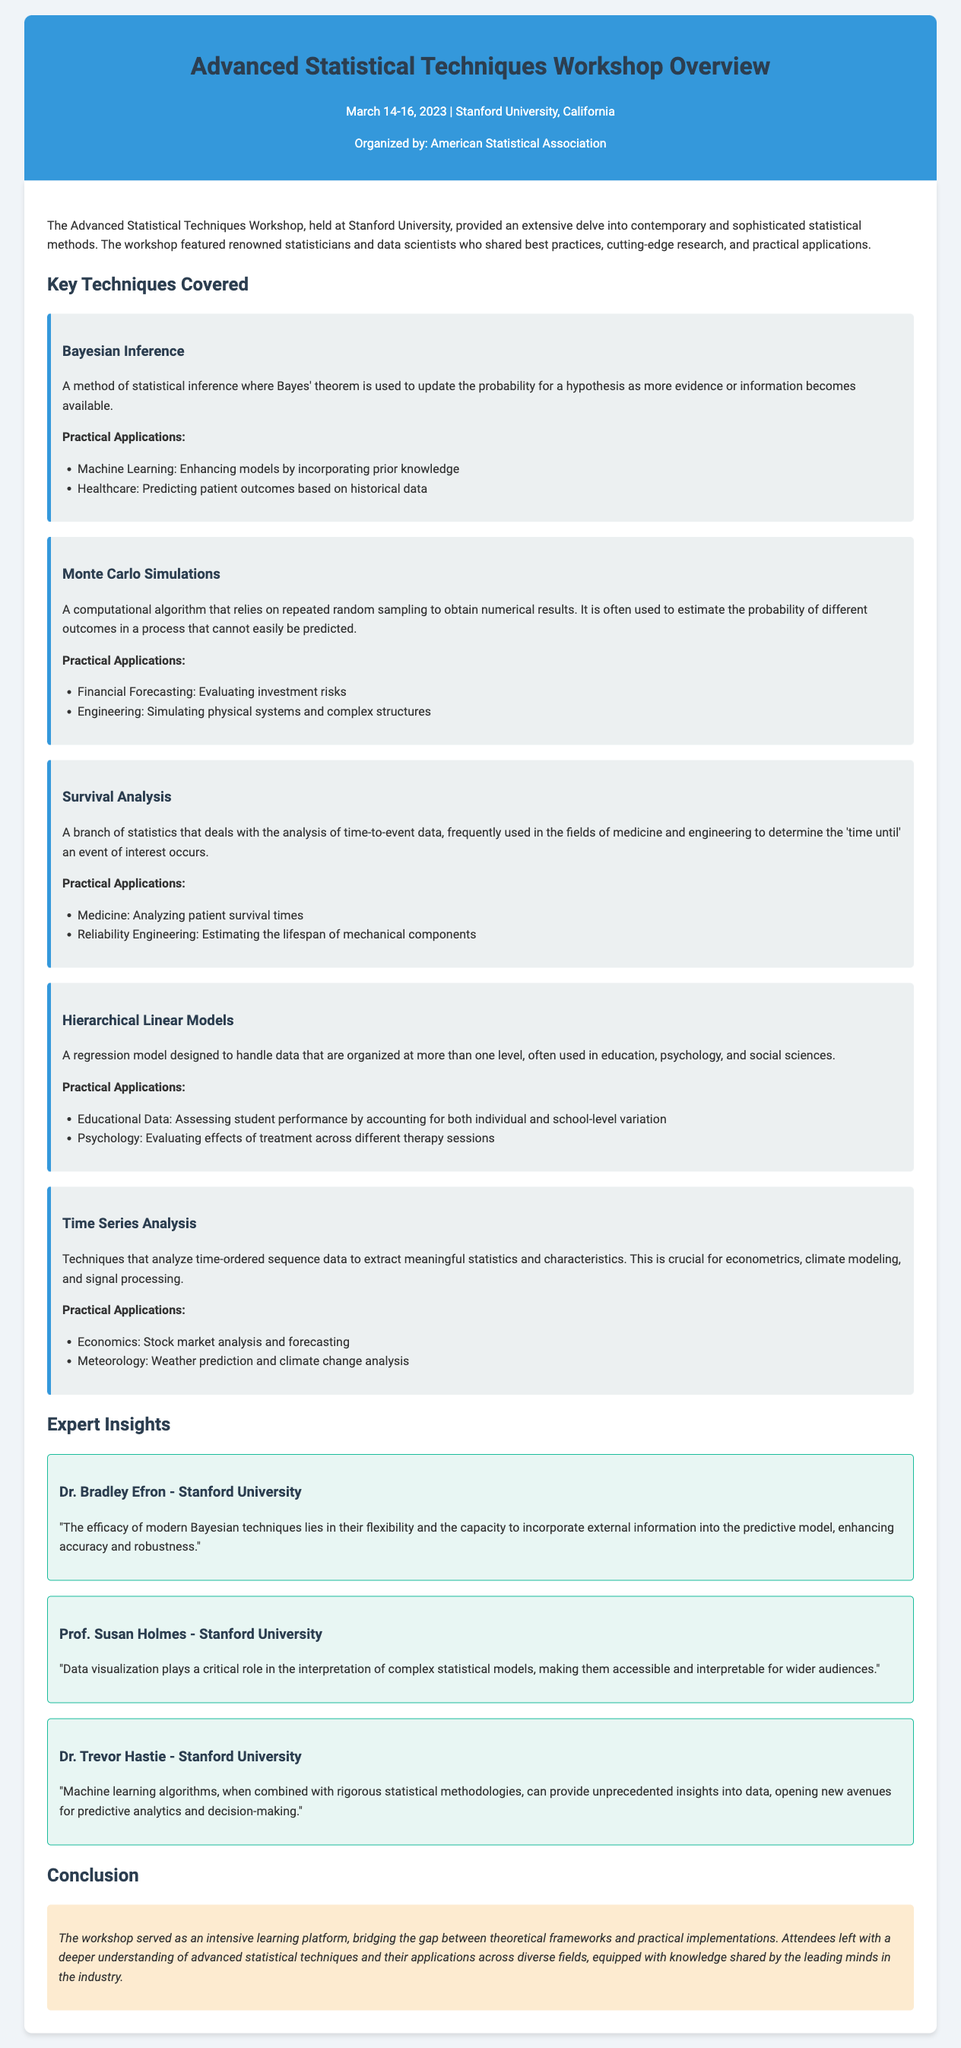What are the dates of the workshop? The workshop took place from March 14 to March 16, 2023.
Answer: March 14-16, 2023 Where was the workshop held? The document states that the workshop was held at Stanford University, California.
Answer: Stanford University, California Who organized the workshop? The organizer of the workshop mentioned in the document is the American Statistical Association.
Answer: American Statistical Association What is one practical application of Bayesian Inference? The document lists several practical applications of Bayesian Inference, one of which is predicting patient outcomes based on historical data.
Answer: Predicting patient outcomes How many expert speakers are mentioned? The document highlights three expert speakers who shared insights during the workshop.
Answer: Three What is the main focus of Survival Analysis? The document describes Survival Analysis as focusing on the analysis of time-to-event data.
Answer: Time-to-event data Which statistical technique is used in educational data assessment? The document points out that Hierarchical Linear Models are specifically used for assessing student performance in education contexts.
Answer: Hierarchical Linear Models What did Dr. Trevor Hastie emphasize about machine learning? According to Dr. Trevor Hastie, machine learning algorithms, when combined with rigorous statistical methodologies, provide unprecedented insights into data.
Answer: Unprecedented insights into data What is the conclusion of the workshop overview? The conclusion emphasizes that attendees left with a deeper understanding of advanced statistical techniques and their applications across diverse fields.
Answer: Deeper understanding of advanced statistical techniques 